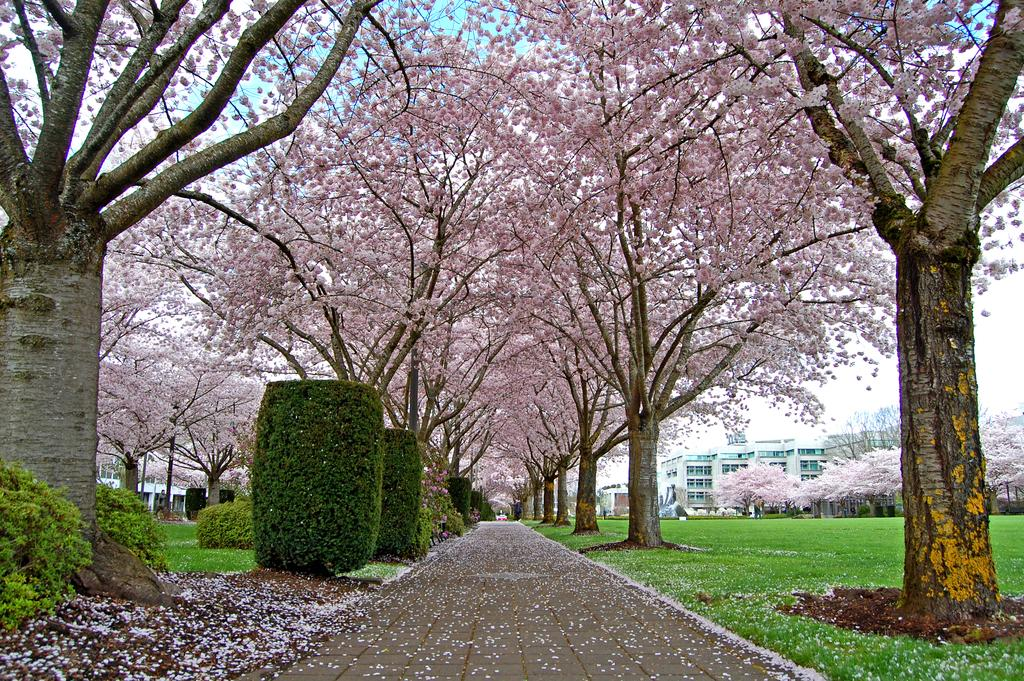What type of vegetation is present in the image? There are trees with flowers, plants, and flowers on the road, and grass visible in the image. What can be seen on the ground in the image? Plants and flowers are present on the road in the image. What is visible in the background of the image? There are buildings and the sky visible in the background of the image. What type of basket can be seen in the image? There is no basket present in the image. 